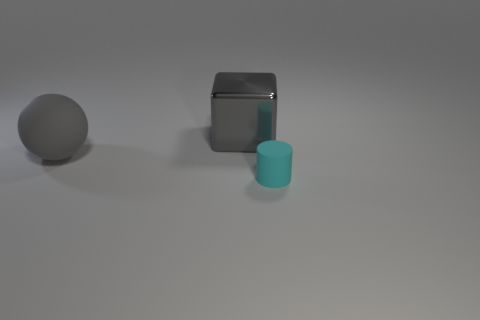Is there any other thing that is the same size as the cyan matte cylinder?
Provide a short and direct response. No. There is a tiny object; does it have the same shape as the matte thing that is behind the small cyan rubber cylinder?
Ensure brevity in your answer.  No. Is there any other thing of the same color as the tiny rubber cylinder?
Your response must be concise. No. There is a rubber thing behind the tiny cyan thing; is its color the same as the large thing that is behind the large rubber thing?
Provide a short and direct response. Yes. Are there any tiny brown metal objects?
Ensure brevity in your answer.  No. Is there another object made of the same material as the cyan thing?
Your response must be concise. Yes. Is there any other thing that has the same material as the gray block?
Offer a very short reply. No. What color is the tiny matte cylinder?
Your answer should be compact. Cyan. There is a large object that is the same color as the ball; what shape is it?
Keep it short and to the point. Cube. There is a shiny cube that is the same size as the gray matte sphere; what color is it?
Offer a terse response. Gray. 